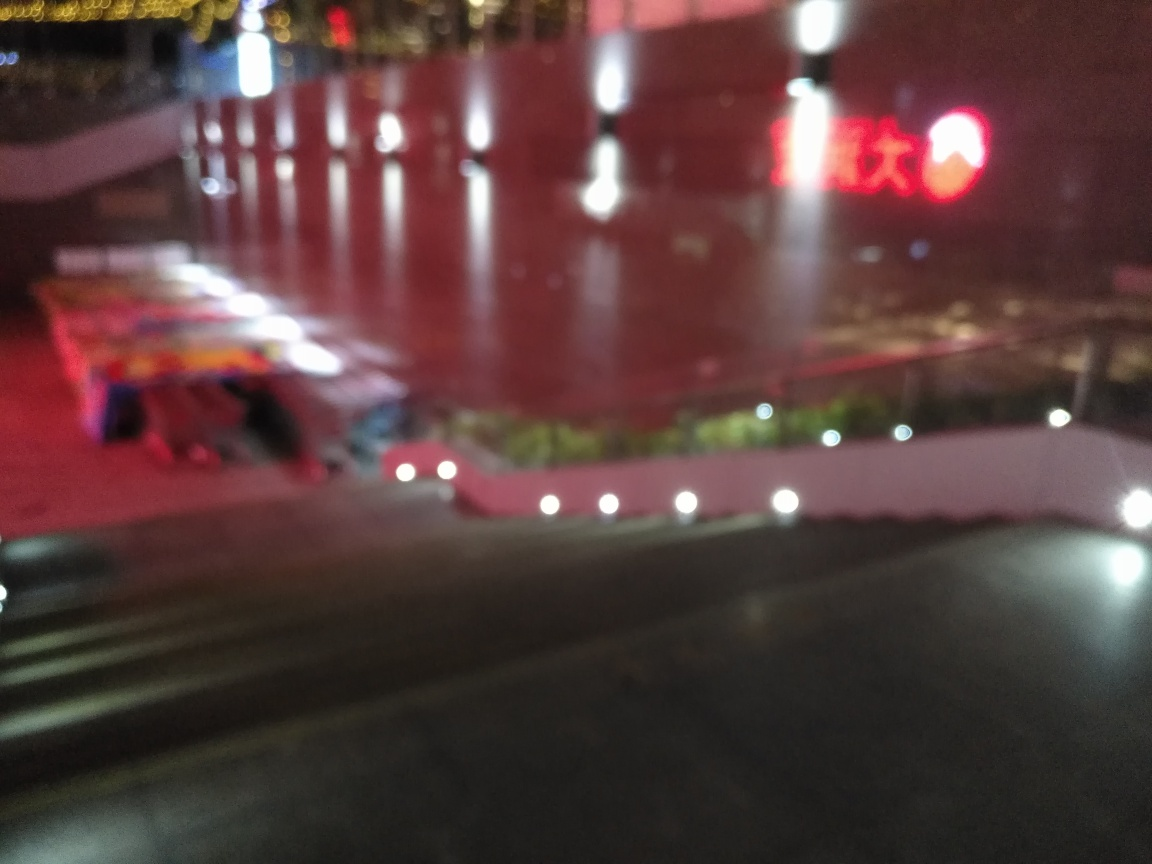What can be observed regarding the lighting in the image? A. underexposed B. properly lit C. overexposed D. well-balanced Answer with the option's letter from the given choices directly. The image appears to be overexposed, as indicated by the excessive brightness and lack of visible detail in several areas. This is particularly evident in the light sources and the reflections on the ground, which suggest an imbalance in the camera's exposure settings at the time of capture. 